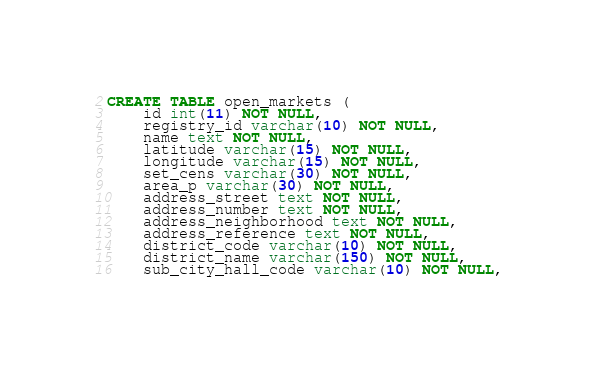<code> <loc_0><loc_0><loc_500><loc_500><_SQL_>CREATE TABLE open_markets (
    id int(11) NOT NULL,
    registry_id varchar(10) NOT NULL,
    name text NOT NULL,
    latitude varchar(15) NOT NULL,
    longitude varchar(15) NOT NULL,
    set_cens varchar(30) NOT NULL,
    area_p varchar(30) NOT NULL,
    address_street text NOT NULL,
    address_number text NOT NULL,
    address_neighborhood text NOT NULL,
    address_reference text NOT NULL,
    district_code varchar(10) NOT NULL,
    district_name varchar(150) NOT NULL,
    sub_city_hall_code varchar(10) NOT NULL,</code> 